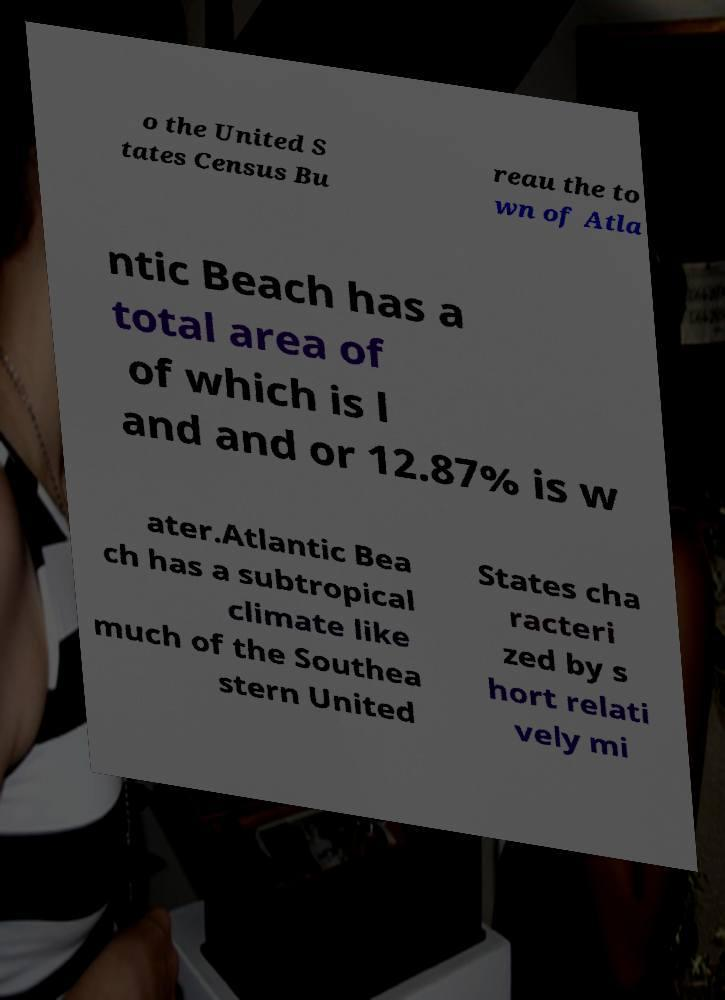I need the written content from this picture converted into text. Can you do that? o the United S tates Census Bu reau the to wn of Atla ntic Beach has a total area of of which is l and and or 12.87% is w ater.Atlantic Bea ch has a subtropical climate like much of the Southea stern United States cha racteri zed by s hort relati vely mi 